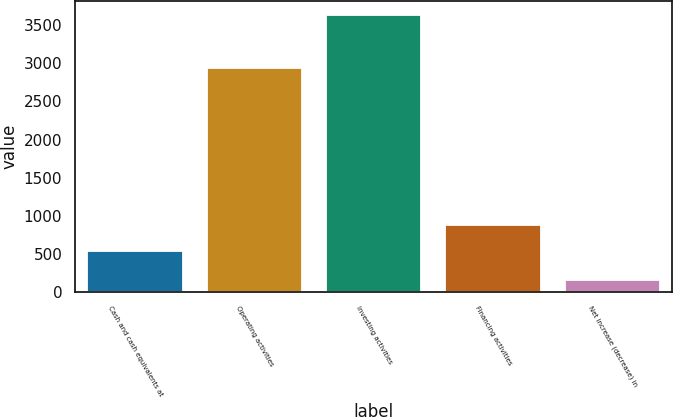Convert chart to OTSL. <chart><loc_0><loc_0><loc_500><loc_500><bar_chart><fcel>Cash and cash equivalents at<fcel>Operating activities<fcel>Investing activities<fcel>Financing activities<fcel>Net increase (decrease) in<nl><fcel>533<fcel>2940<fcel>3639<fcel>880.8<fcel>161<nl></chart> 